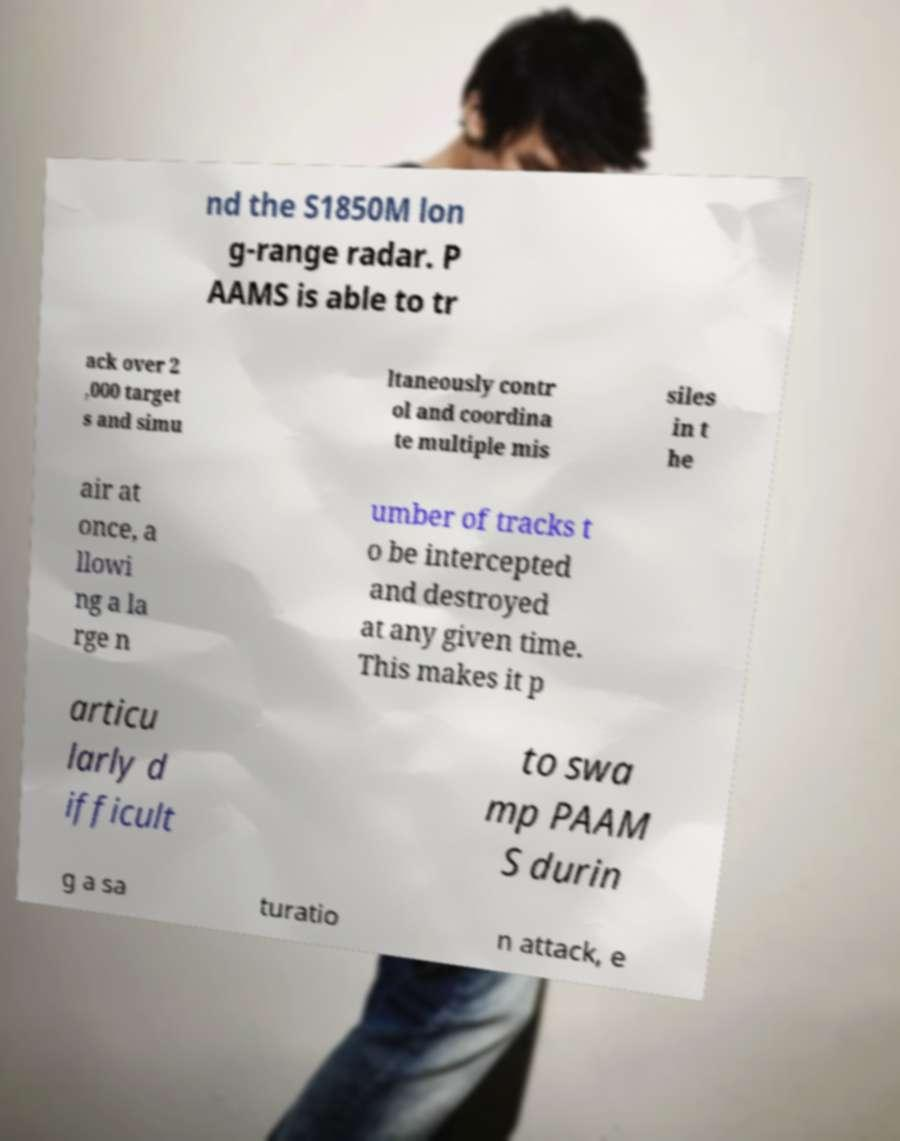Please identify and transcribe the text found in this image. nd the S1850M lon g-range radar. P AAMS is able to tr ack over 2 ,000 target s and simu ltaneously contr ol and coordina te multiple mis siles in t he air at once, a llowi ng a la rge n umber of tracks t o be intercepted and destroyed at any given time. This makes it p articu larly d ifficult to swa mp PAAM S durin g a sa turatio n attack, e 